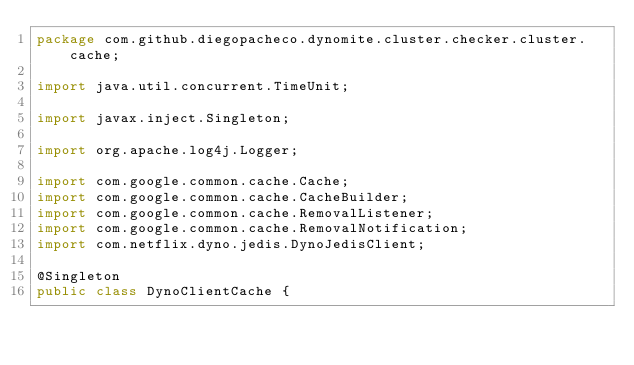<code> <loc_0><loc_0><loc_500><loc_500><_Java_>package com.github.diegopacheco.dynomite.cluster.checker.cluster.cache;

import java.util.concurrent.TimeUnit;

import javax.inject.Singleton;

import org.apache.log4j.Logger;

import com.google.common.cache.Cache;
import com.google.common.cache.CacheBuilder;
import com.google.common.cache.RemovalListener;
import com.google.common.cache.RemovalNotification;
import com.netflix.dyno.jedis.DynoJedisClient;

@Singleton
public class DynoClientCache {
</code> 